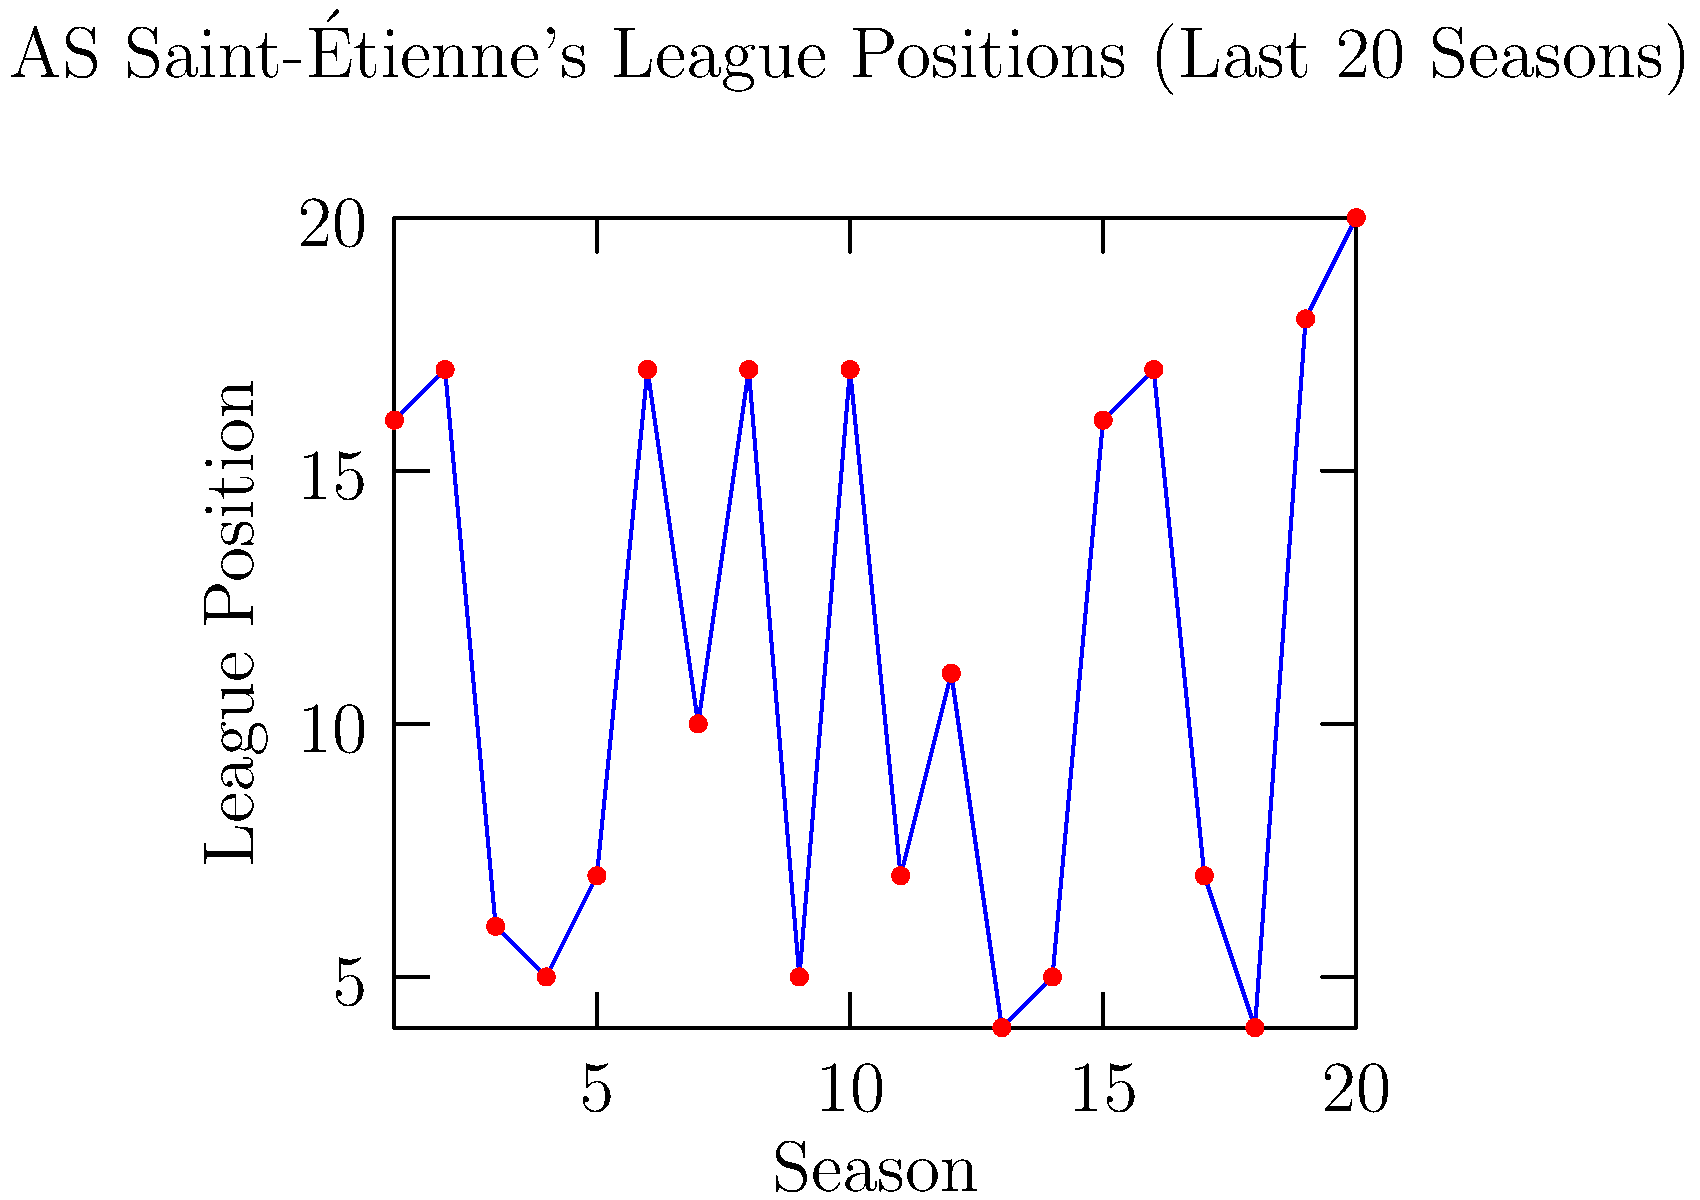Based on the line graph showing AS Saint-Étienne's league positions over the past 20 seasons, in how many seasons did the team finish in the top 5 positions? To answer this question, we need to count the number of times AS Saint-Étienne finished in positions 1-5 over the 20 seasons shown in the graph. Let's go through the data step-by-step:

1. Scan the y-axis (League Position) for values 5 or lower.
2. Count the occurrences:
   - Season 3: 6th position (not counted)
   - Season 4: 5th position (count: 1)
   - Season 9: 5th position (count: 2)
   - Season 13: 4th position (count: 3)
   - Season 14: 5th position (count: 4)
   - Season 18: 4th position (count: 5)

3. Total count: 5 seasons

Therefore, AS Saint-Étienne finished in the top 5 positions in 5 seasons out of the last 20.
Answer: 5 seasons 